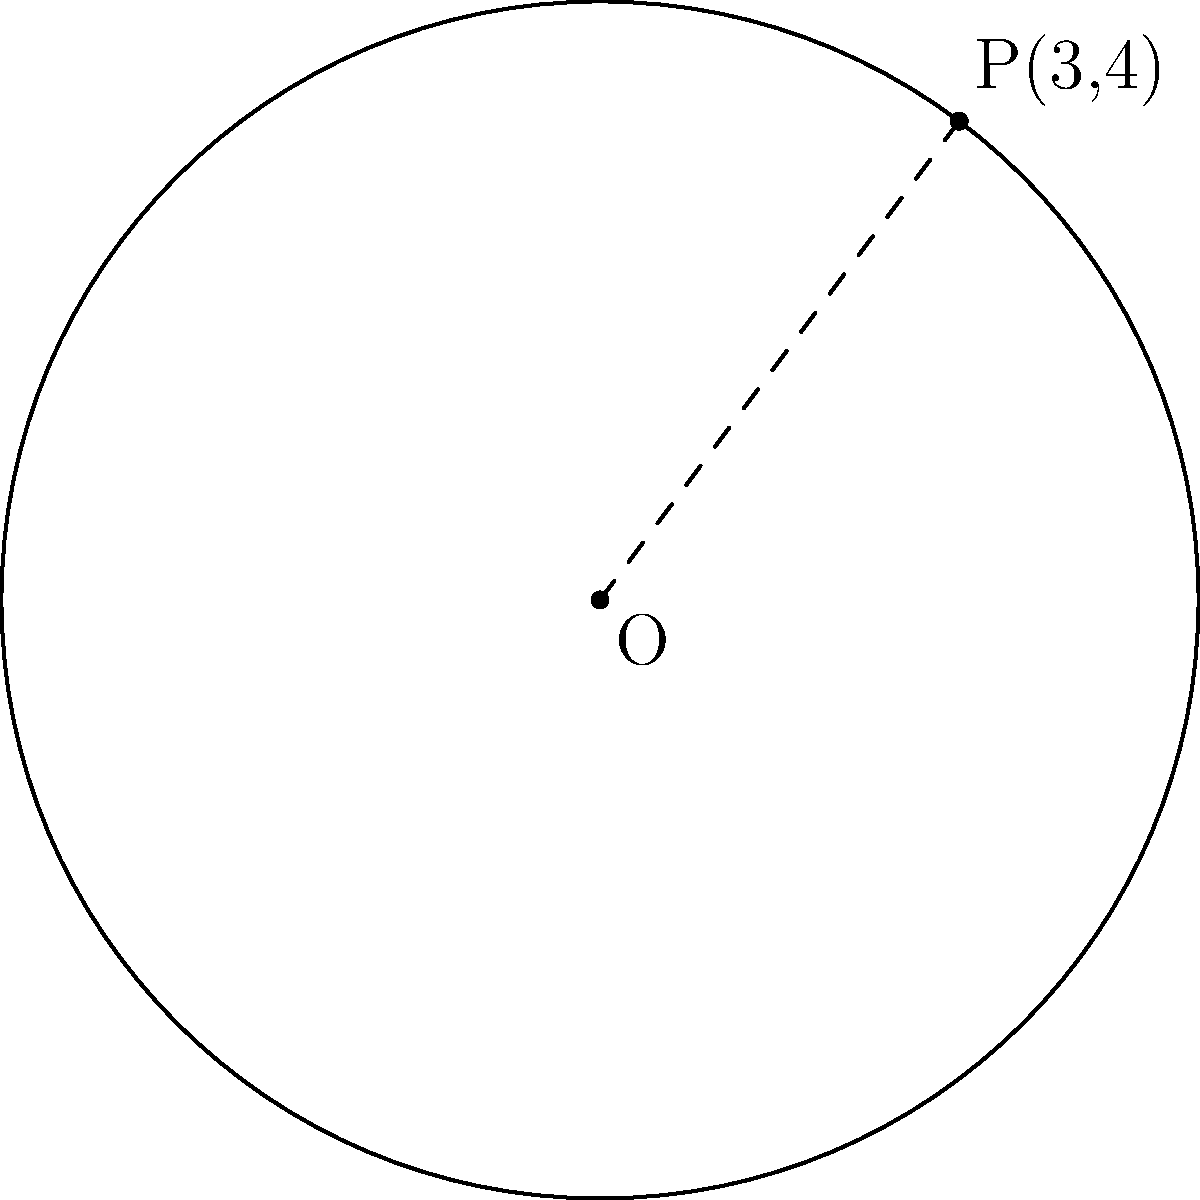Yo, check out this circle with its center at the origin (0,0) and a point P(3,4) on its circumference. What's the equation of this circle? Keep it simple, dude! Alright, let's break this down step by step:

1) The general equation of a circle is $$(x-h)^2 + (y-k)^2 = r^2$$
   where (h,k) is the center and r is the radius.

2) We're told the center is at the origin (0,0), so h = 0 and k = 0.

3) To find r, we can use the distance formula between the center (0,0) and the point P(3,4):

   $$r^2 = (3-0)^2 + (4-0)^2 = 3^2 + 4^2 = 9 + 16 = 25$$

4) So, r = 5 (we take the positive square root since radius is always positive).

5) Now, let's plug everything into our general equation:

   $$(x-0)^2 + (y-0)^2 = 5^2$$

6) Simplify:

   $$x^2 + y^2 = 25$$

And that's our equation! Pretty chill, right?
Answer: $x^2 + y^2 = 25$ 